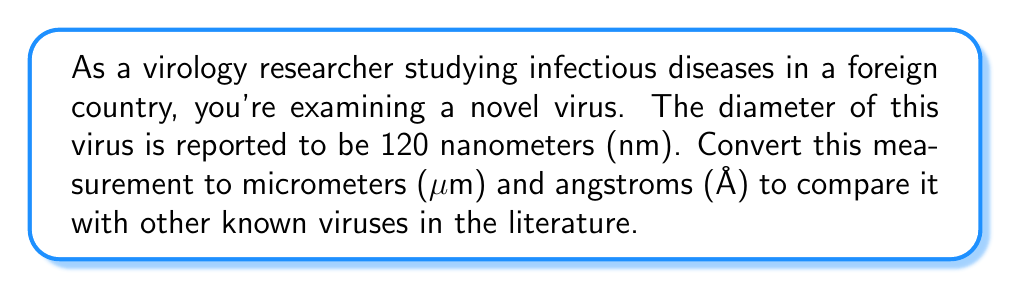Can you answer this question? To solve this problem, we need to understand the relationships between different units of measurement for viral particle sizes:

1. 1 micrometer (μm) = 1000 nanometers (nm)
2. 1 nanometer (nm) = 10 angstroms (Å)

Let's convert 120 nm to μm:

$$\text{120 nm} \times \frac{1 \mu m}{1000 \text{ nm}} = 0.12 \mu m$$

Now, let's convert 120 nm to Å:

$$\text{120 nm} \times \frac{10 \text{ Å}}{1 \text{ nm}} = 1200 \text{ Å}$$

Therefore, the virus with a diameter of 120 nm is equivalent to 0.12 μm and 1200 Å.
Answer: The virus diameter is equivalent to $0.12 \mu m$ and $1200 \text{ Å}$. 